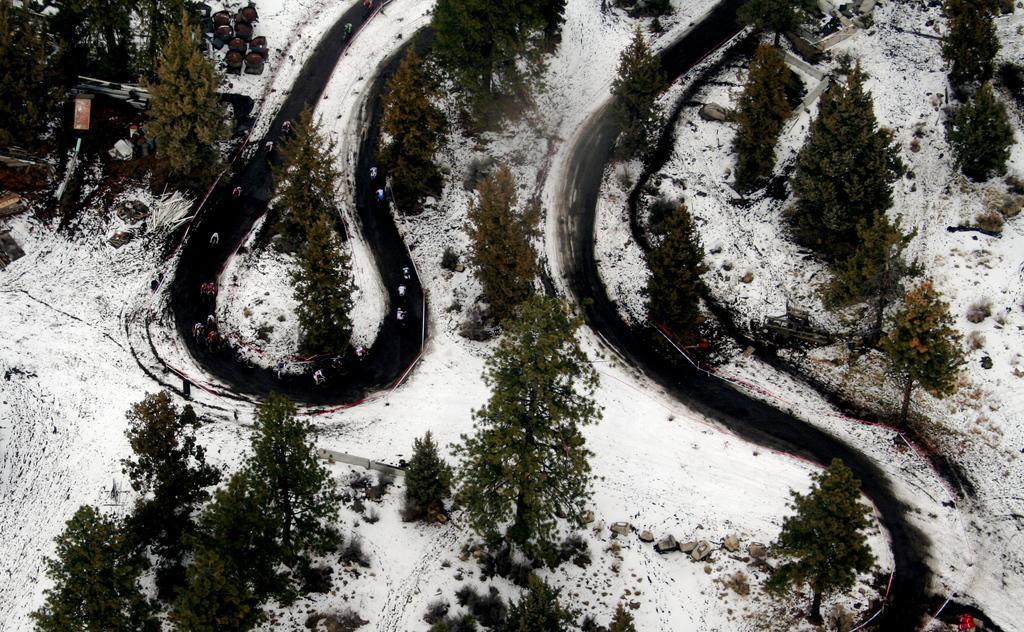Can you describe this image briefly? In this image, we can see some roads, there is snow on the ground, we can see some trees. 